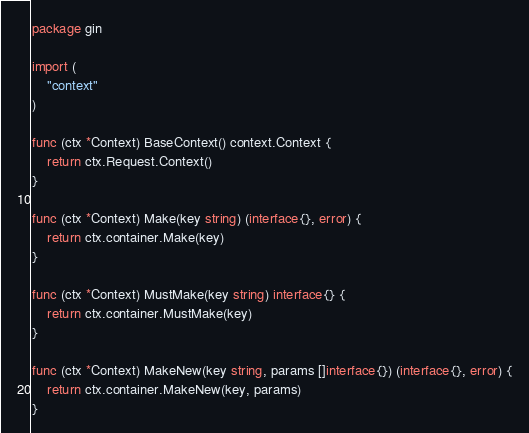Convert code to text. <code><loc_0><loc_0><loc_500><loc_500><_Go_>package gin

import (
	"context"
)

func (ctx *Context) BaseContext() context.Context {
	return ctx.Request.Context()
}

func (ctx *Context) Make(key string) (interface{}, error) {
	return ctx.container.Make(key)
}

func (ctx *Context) MustMake(key string) interface{} {
	return ctx.container.MustMake(key)
}

func (ctx *Context) MakeNew(key string, params []interface{}) (interface{}, error) {
	return ctx.container.MakeNew(key, params)
}
</code> 